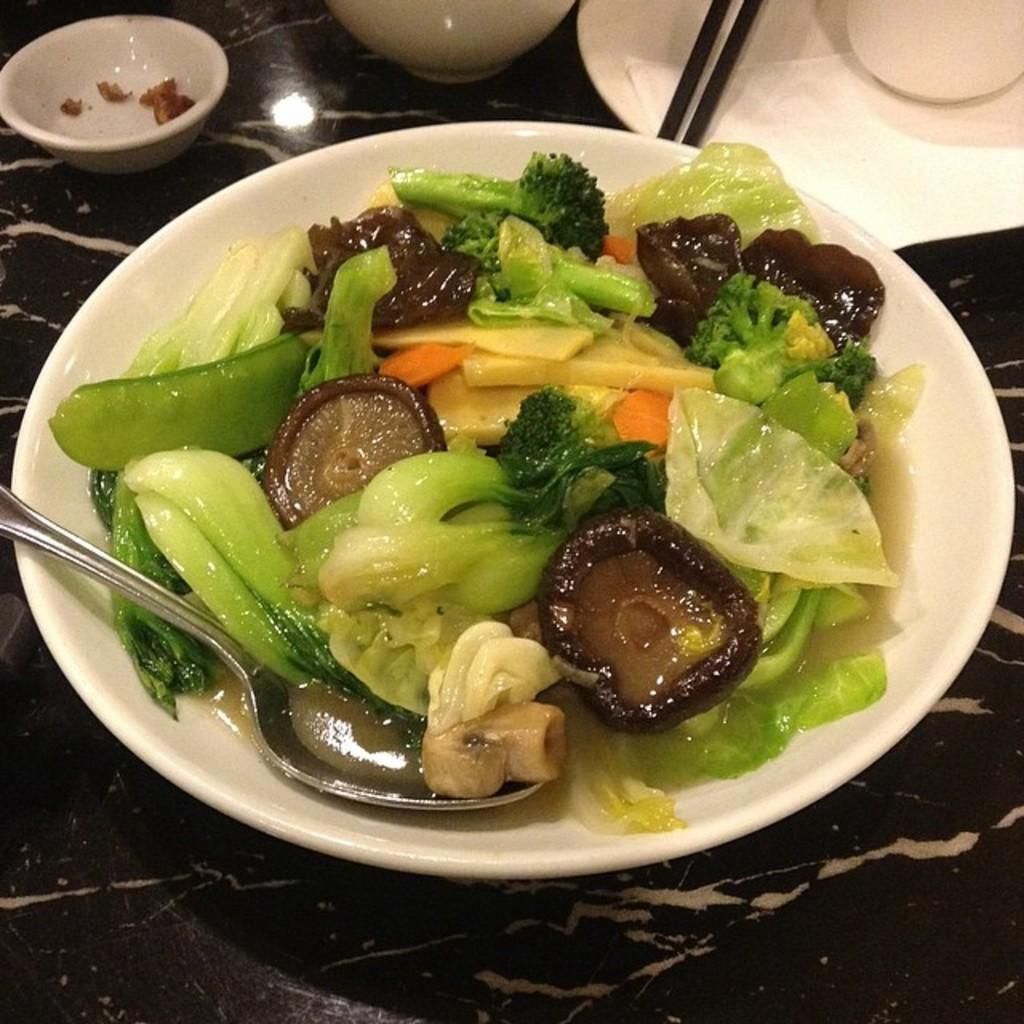What utensil is visible in the image? There is a spoon in the image. What is on the plate in the image? There is food in a plate in the image. What can be seen in the background of the image? There is a bowl and chopsticks in the background of the image. What else is on the table in the background of the image? There are other things on the table in the background of the image. What type of disease is being treated in the image? There is no indication of a disease or treatment in the image; it primarily features a spoon, food on a plate, and items in the background. 